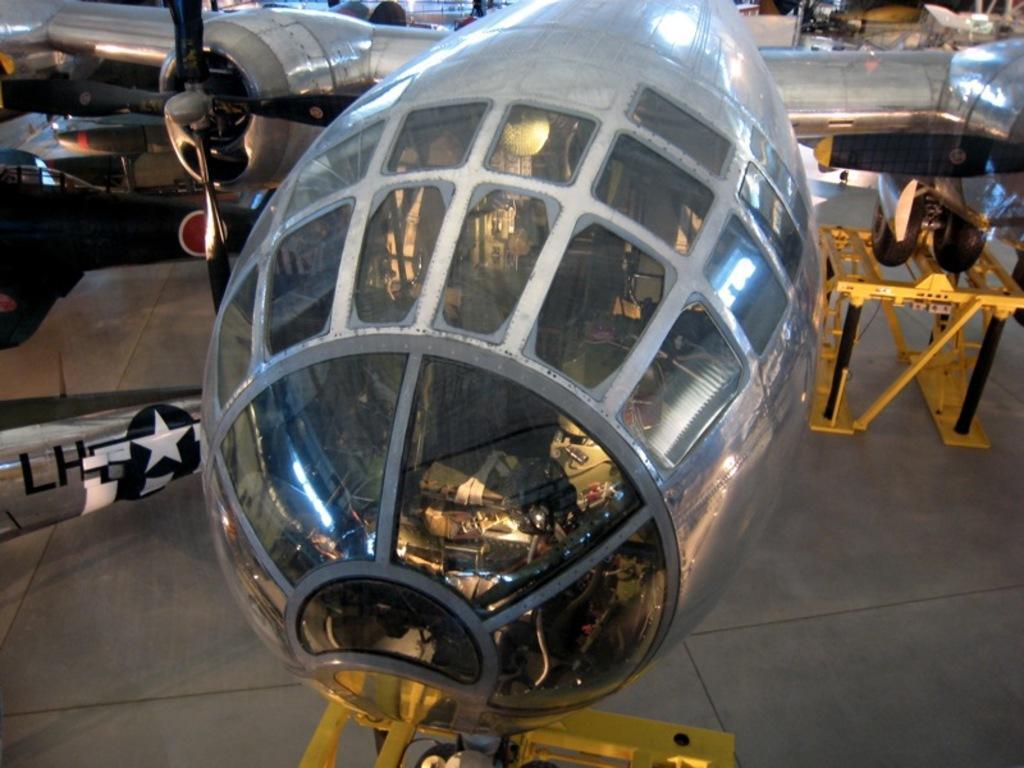Could you give a brief overview of what you see in this image? In the picture we can see a air craft on the path which is gray in color with glasses to it and under it we can see some stands which are yellow in color. 